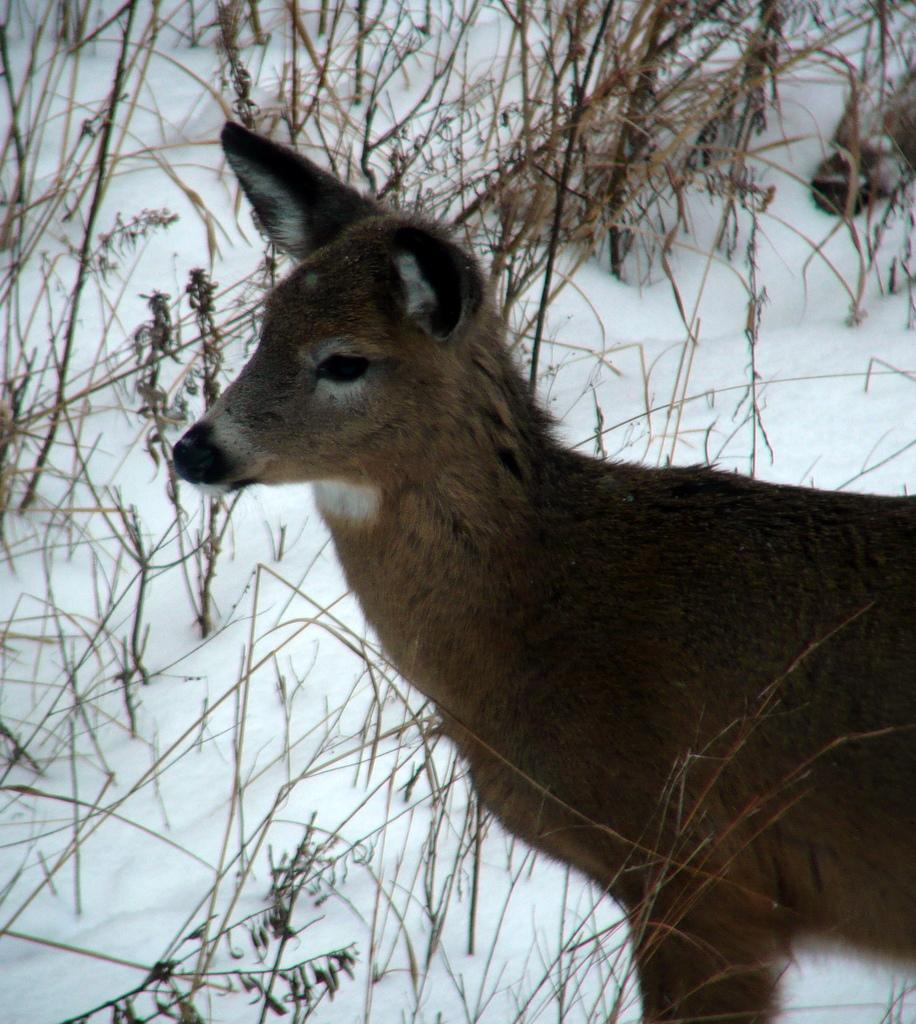What type of animal is in the image? There is a white-tailed deer in the image. What is the ground covered with in the image? There is snow and grass visible in the image. What type of leg is being offered to the deer in the image? There is no leg or any human presence in the image; it only features a white-tailed deer in a snowy and grassy environment. 